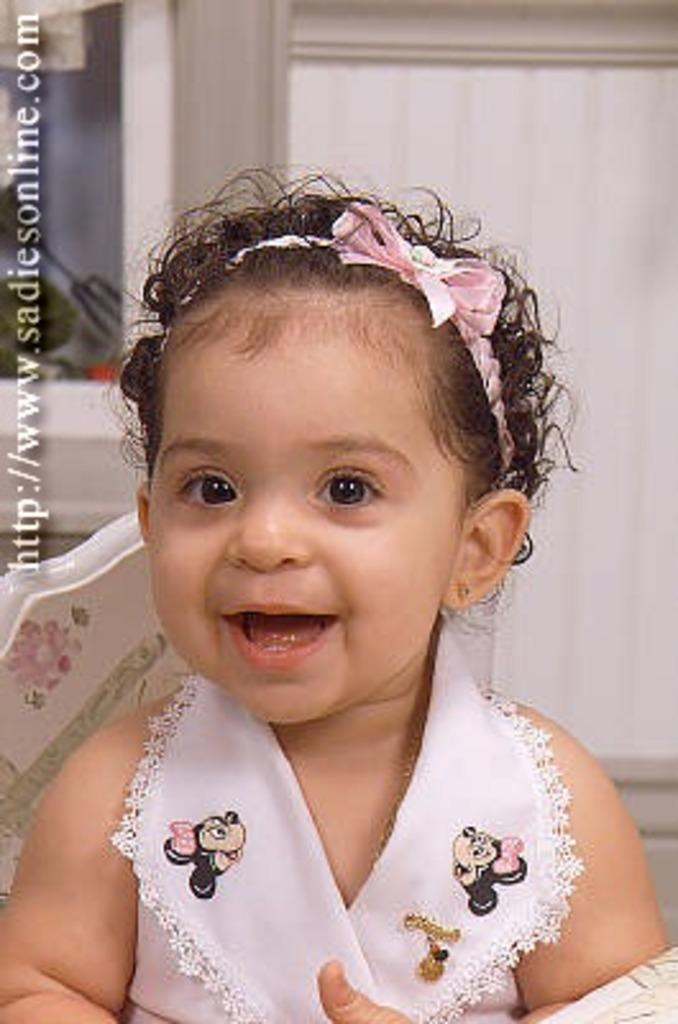Who is the main subject in the picture? There is a girl in the picture. What expression does the girl have on her face? The girl has a pretty smile on her face. What type of cloud can be seen in the girl's veins in the image? There is no cloud or vein visible in the image; it only features a girl with a smile. 